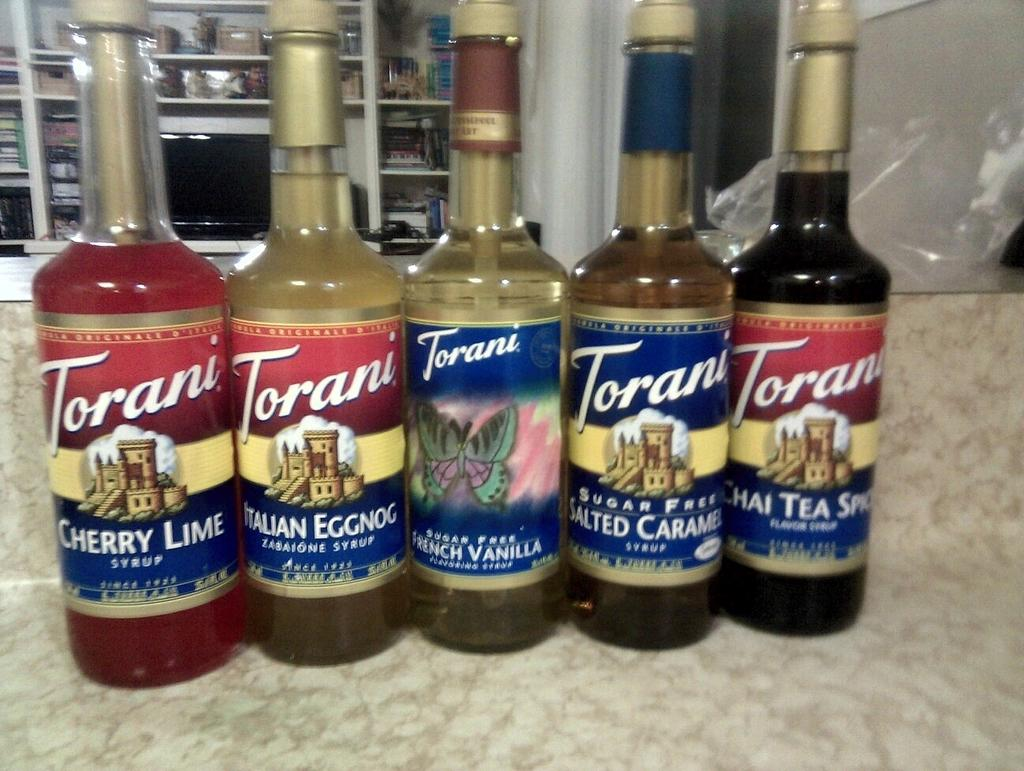Provide a one-sentence caption for the provided image. Several bottles of Torani sit in a row on counter. 